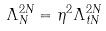Convert formula to latex. <formula><loc_0><loc_0><loc_500><loc_500>\Lambda _ { N } ^ { 2 N } = \eta ^ { 2 } \Lambda _ { t N } ^ { 2 N }</formula> 